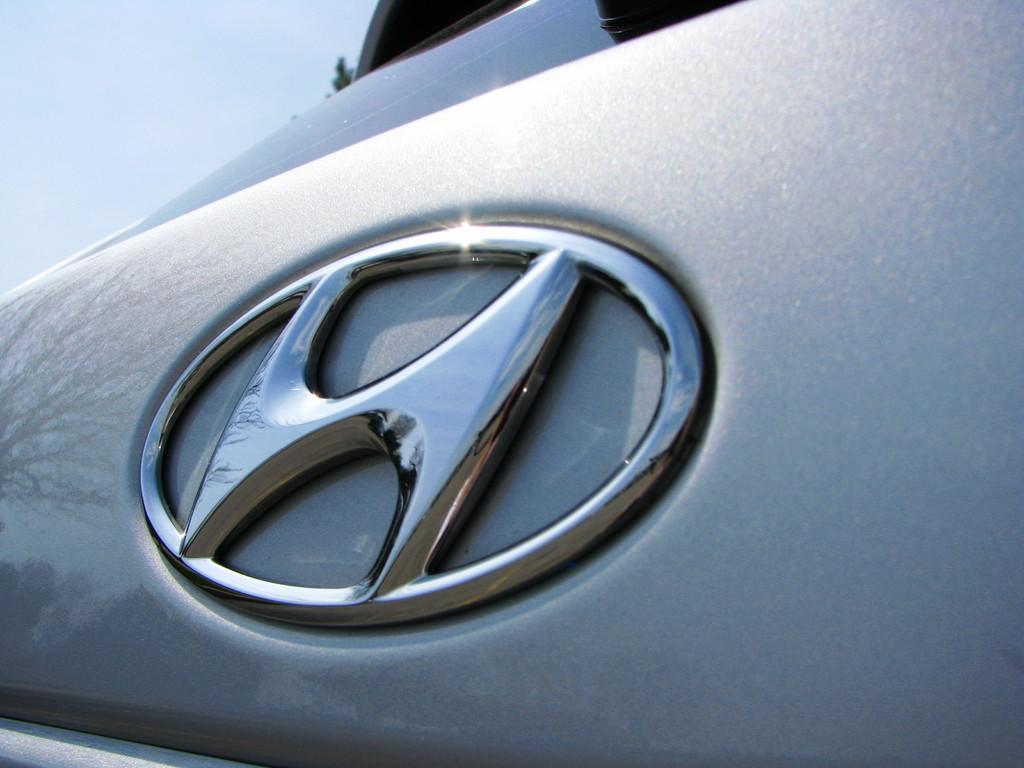What is the main subject of the picture? The main subject of the picture is a car. What is the condition of the sky in the picture? The sky is clear in the picture. What is the weather like in the image? It is sunny in the image. Can you describe any additional details about the car? There is a reflection of a tree on the car. What is the tendency of the cup to spill in the image? There is no cup present in the image, so it is not possible to determine its tendency to spill. 